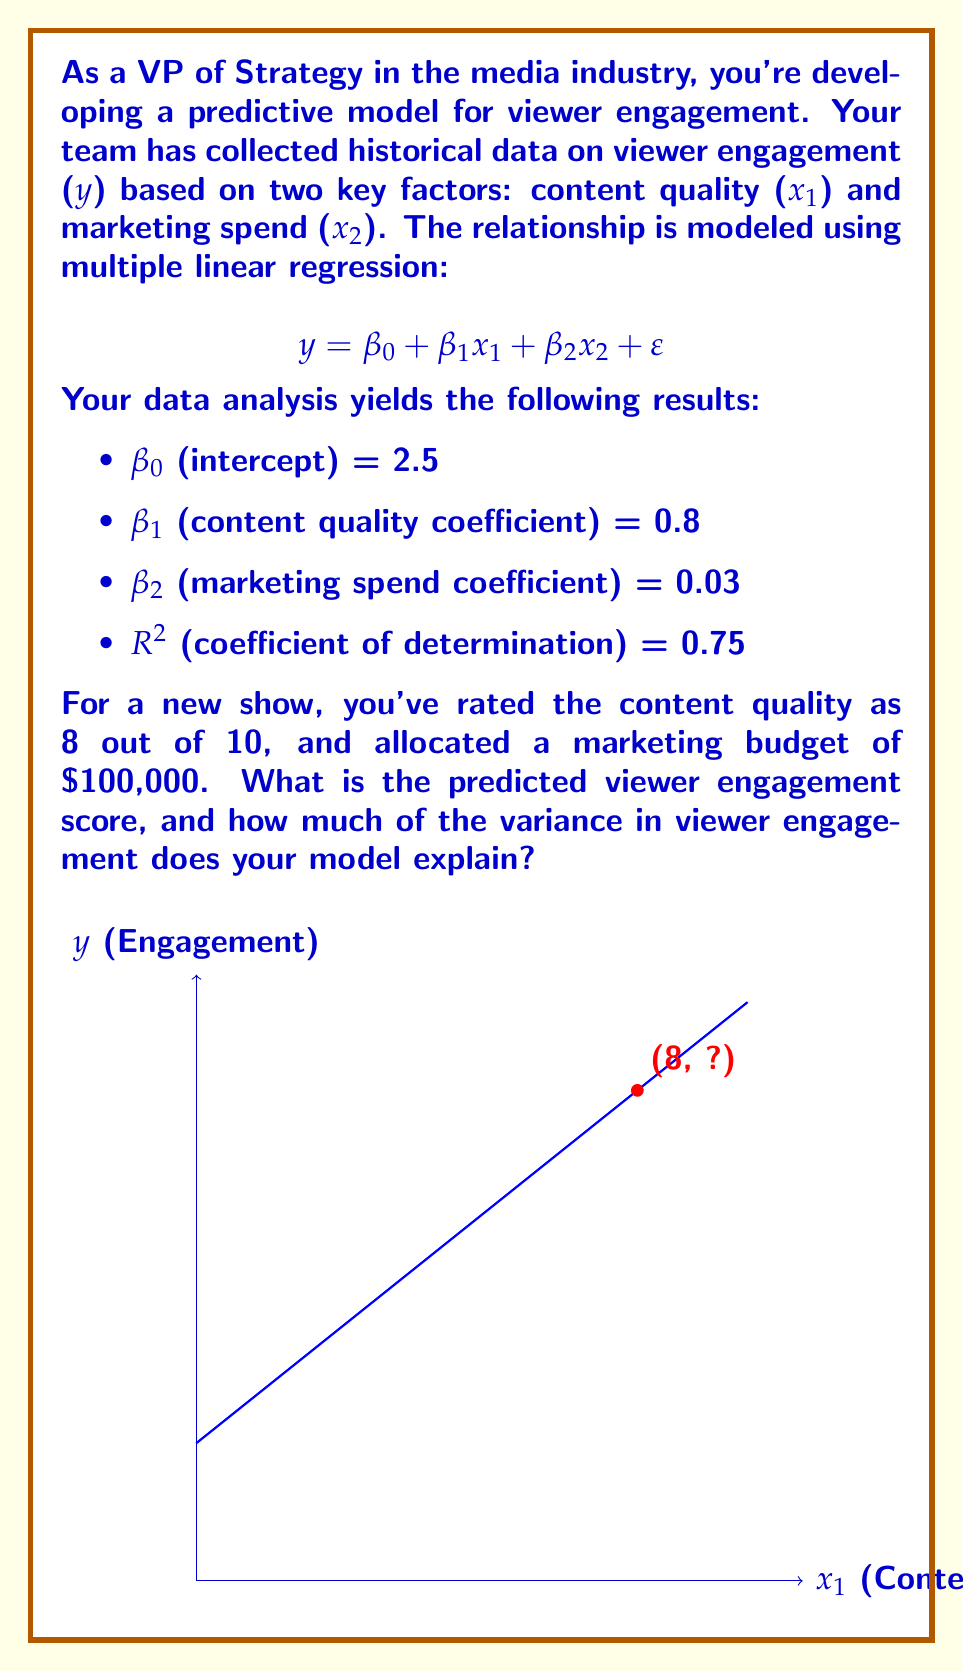Provide a solution to this math problem. Let's approach this step-by-step:

1) We have the multiple linear regression model:
   $$y = β₀ + β₁x₁ + β₂x₂ + ε$$

2) Given coefficients:
   β₀ = 2.5
   β₁ = 0.8
   β₂ = 0.03

3) We're given:
   x₁ (content quality) = 8
   x₂ (marketing spend) = 100,000

4) Let's substitute these values into our model:
   $$y = 2.5 + 0.8(8) + 0.03(100,000)$$

5) Simplify:
   $$y = 2.5 + 6.4 + 3000$$
   $$y = 3008.9$$

6) Therefore, the predicted viewer engagement score is 3008.9.

7) The R² value of 0.75 indicates that 75% of the variance in viewer engagement is explained by our model.
Answer: Predicted engagement: 3008.9; Model explains 75% of variance 